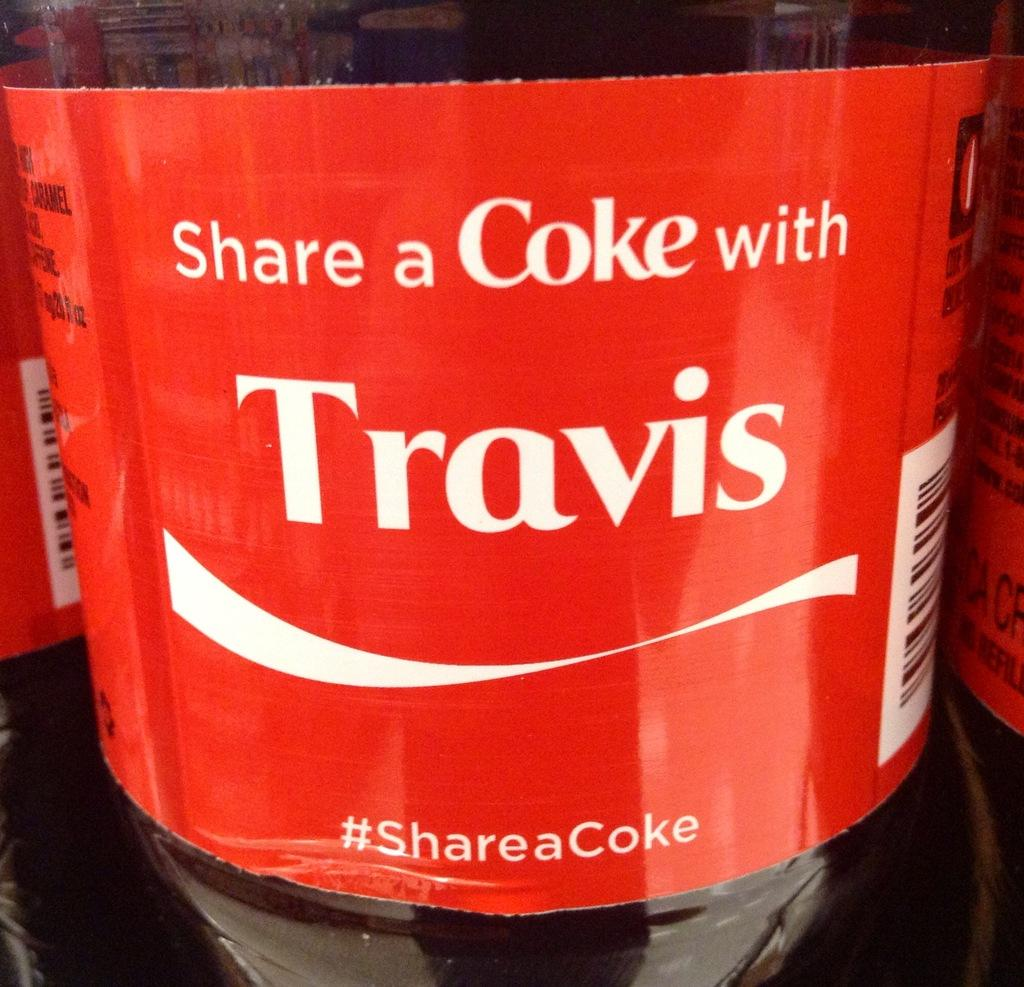<image>
Write a terse but informative summary of the picture. a coke bottle with a red label on it that says 'share a coke with travis' 